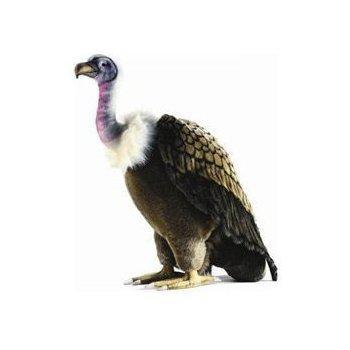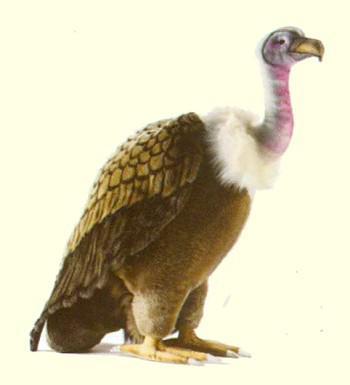The first image is the image on the left, the second image is the image on the right. Assess this claim about the two images: "1 bird is facing left and 1 bird is facing right.". Correct or not? Answer yes or no. Yes. 